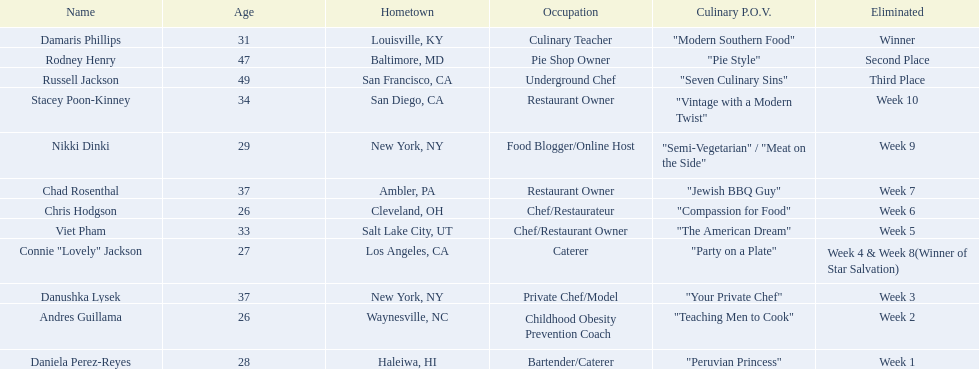Who are the people competing? Damaris Phillips, Rodney Henry, Russell Jackson, Stacey Poon-Kinney, Nikki Dinki, Chad Rosenthal, Chris Hodgson, Viet Pham, Connie "Lovely" Jackson, Danushka Lysek, Andres Guillama, Daniela Perez-Reyes. What are their distinct culinary viewpoints? "Modern Southern Food", "Pie Style", "Seven Culinary Sins", "Vintage with a Modern Twist", "Semi-Vegetarian" / "Meat on the Side", "Jewish BBQ Guy", "Compassion for Food", "The American Dream", "Party on a Plate", "Your Private Chef", "Teaching Men to Cook", "Peruvian Princess". And which contestant has the most comprehensive viewpoint? Nikki Dinki. 